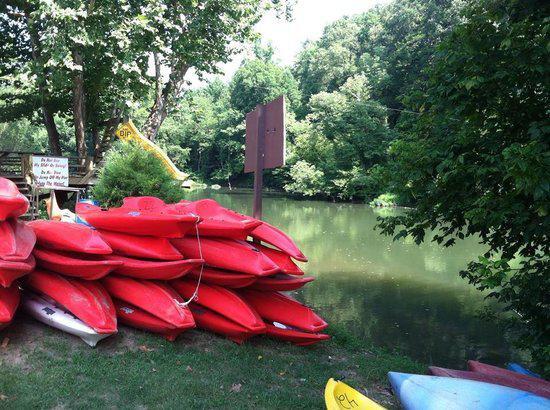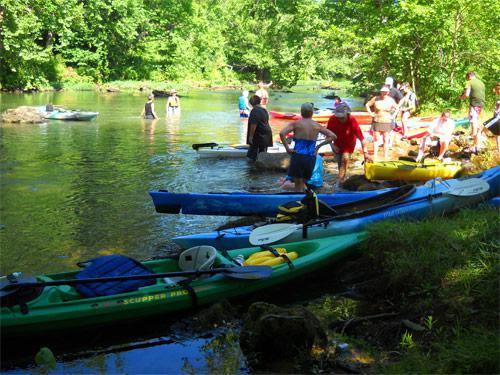The first image is the image on the left, the second image is the image on the right. Given the left and right images, does the statement "A person is in the water in a red kayak in the image on the right." hold true? Answer yes or no. No. The first image is the image on the left, the second image is the image on the right. Considering the images on both sides, is "An image shows a woman in a life vest and sunglasses holding a raised oar while sitting in a canoe on the water." valid? Answer yes or no. No. 